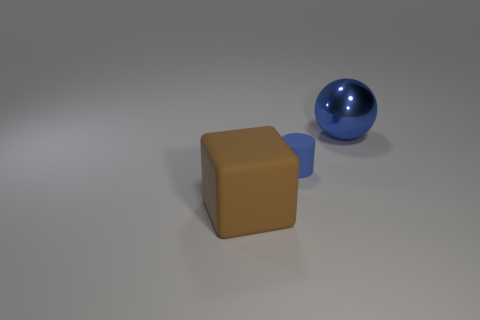Are there more large things that are to the left of the big blue object than cubes that are to the left of the large brown object?
Provide a succinct answer. Yes. What is the size of the thing to the right of the blue object that is on the left side of the blue thing that is behind the tiny blue rubber thing?
Make the answer very short. Large. Are there any large objects that have the same color as the tiny matte object?
Make the answer very short. Yes. What number of green objects are there?
Your response must be concise. 0. What is the material of the blue object that is on the right side of the rubber object behind the thing to the left of the small blue matte cylinder?
Provide a succinct answer. Metal. Are there any large green cylinders made of the same material as the big blue sphere?
Keep it short and to the point. No. Are the blue ball and the blue cylinder made of the same material?
Make the answer very short. No. How many spheres are large brown matte objects or tiny blue objects?
Your answer should be very brief. 0. There is a cylinder that is the same material as the large brown object; what color is it?
Offer a very short reply. Blue. Is the number of tiny blue rubber cylinders less than the number of large cyan objects?
Make the answer very short. No. 